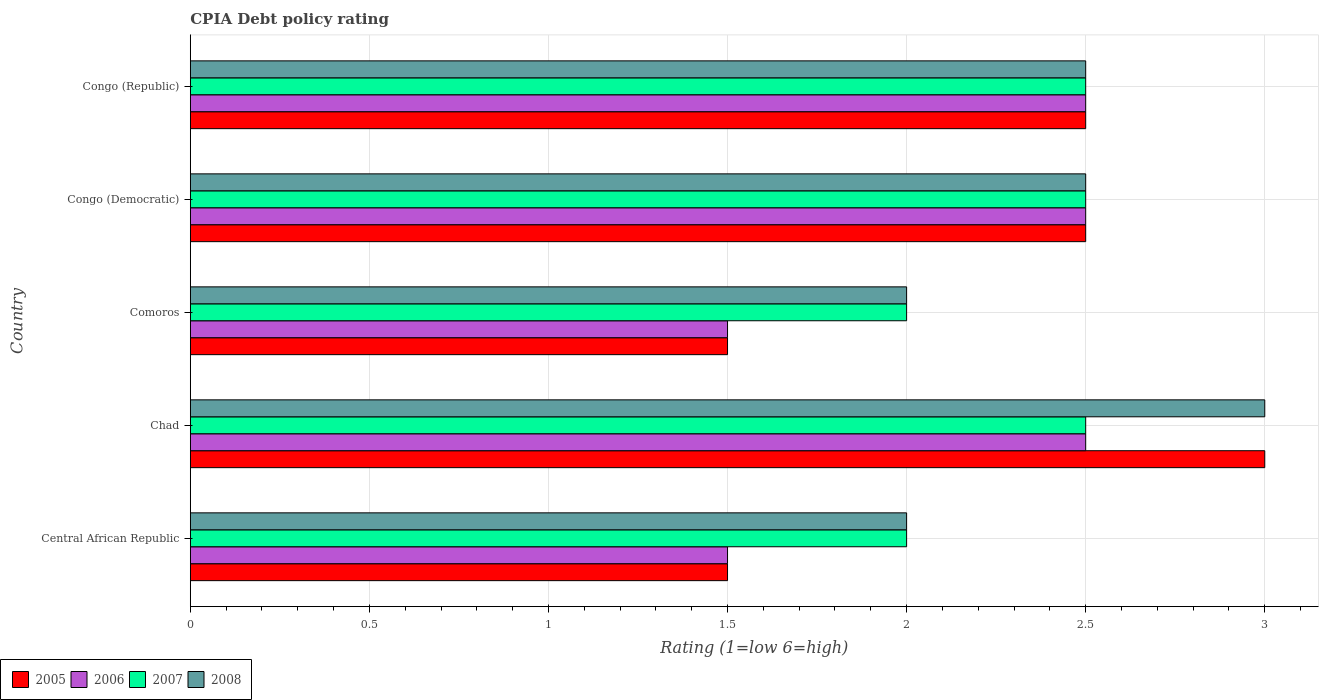How many different coloured bars are there?
Your answer should be very brief. 4. Are the number of bars per tick equal to the number of legend labels?
Your answer should be compact. Yes. How many bars are there on the 3rd tick from the bottom?
Your answer should be very brief. 4. What is the label of the 3rd group of bars from the top?
Your answer should be compact. Comoros. What is the CPIA rating in 2008 in Chad?
Offer a very short reply. 3. Across all countries, what is the maximum CPIA rating in 2007?
Keep it short and to the point. 2.5. Across all countries, what is the minimum CPIA rating in 2007?
Give a very brief answer. 2. In which country was the CPIA rating in 2005 maximum?
Give a very brief answer. Chad. In which country was the CPIA rating in 2007 minimum?
Make the answer very short. Central African Republic. What is the total CPIA rating in 2007 in the graph?
Ensure brevity in your answer.  11.5. What is the difference between the CPIA rating in 2005 in Comoros and that in Congo (Republic)?
Provide a short and direct response. -1. What is the difference between the CPIA rating in 2005 in Congo (Republic) and the CPIA rating in 2008 in Central African Republic?
Keep it short and to the point. 0.5. What is the average CPIA rating in 2007 per country?
Keep it short and to the point. 2.3. What is the ratio of the CPIA rating in 2007 in Central African Republic to that in Comoros?
Your response must be concise. 1. Is the CPIA rating in 2007 in Congo (Democratic) less than that in Congo (Republic)?
Your response must be concise. No. Is the sum of the CPIA rating in 2008 in Congo (Democratic) and Congo (Republic) greater than the maximum CPIA rating in 2005 across all countries?
Keep it short and to the point. Yes. What does the 2nd bar from the top in Comoros represents?
Provide a succinct answer. 2007. How many bars are there?
Your answer should be compact. 20. Are all the bars in the graph horizontal?
Offer a terse response. Yes. How many countries are there in the graph?
Provide a succinct answer. 5. Are the values on the major ticks of X-axis written in scientific E-notation?
Your response must be concise. No. Does the graph contain any zero values?
Your answer should be compact. No. What is the title of the graph?
Your answer should be compact. CPIA Debt policy rating. Does "1988" appear as one of the legend labels in the graph?
Make the answer very short. No. What is the Rating (1=low 6=high) in 2006 in Central African Republic?
Offer a very short reply. 1.5. What is the Rating (1=low 6=high) in 2007 in Central African Republic?
Provide a short and direct response. 2. What is the Rating (1=low 6=high) of 2008 in Central African Republic?
Your answer should be very brief. 2. What is the Rating (1=low 6=high) of 2006 in Chad?
Ensure brevity in your answer.  2.5. What is the Rating (1=low 6=high) in 2008 in Chad?
Ensure brevity in your answer.  3. What is the Rating (1=low 6=high) of 2005 in Comoros?
Offer a terse response. 1.5. What is the Rating (1=low 6=high) of 2006 in Comoros?
Provide a succinct answer. 1.5. What is the Rating (1=low 6=high) of 2008 in Comoros?
Offer a very short reply. 2. What is the Rating (1=low 6=high) of 2005 in Congo (Republic)?
Your answer should be very brief. 2.5. What is the Rating (1=low 6=high) in 2006 in Congo (Republic)?
Your answer should be very brief. 2.5. What is the Rating (1=low 6=high) of 2007 in Congo (Republic)?
Your response must be concise. 2.5. What is the Rating (1=low 6=high) in 2008 in Congo (Republic)?
Your response must be concise. 2.5. Across all countries, what is the maximum Rating (1=low 6=high) of 2005?
Your response must be concise. 3. Across all countries, what is the maximum Rating (1=low 6=high) of 2006?
Offer a terse response. 2.5. Across all countries, what is the minimum Rating (1=low 6=high) in 2005?
Offer a very short reply. 1.5. Across all countries, what is the minimum Rating (1=low 6=high) in 2006?
Keep it short and to the point. 1.5. What is the total Rating (1=low 6=high) of 2006 in the graph?
Your answer should be compact. 10.5. What is the difference between the Rating (1=low 6=high) of 2005 in Central African Republic and that in Chad?
Your answer should be compact. -1.5. What is the difference between the Rating (1=low 6=high) in 2006 in Central African Republic and that in Chad?
Your answer should be compact. -1. What is the difference between the Rating (1=low 6=high) in 2008 in Central African Republic and that in Chad?
Keep it short and to the point. -1. What is the difference between the Rating (1=low 6=high) of 2005 in Central African Republic and that in Comoros?
Your answer should be very brief. 0. What is the difference between the Rating (1=low 6=high) of 2006 in Central African Republic and that in Comoros?
Keep it short and to the point. 0. What is the difference between the Rating (1=low 6=high) in 2008 in Central African Republic and that in Comoros?
Make the answer very short. 0. What is the difference between the Rating (1=low 6=high) in 2005 in Central African Republic and that in Congo (Democratic)?
Offer a terse response. -1. What is the difference between the Rating (1=low 6=high) in 2007 in Central African Republic and that in Congo (Democratic)?
Provide a short and direct response. -0.5. What is the difference between the Rating (1=low 6=high) of 2008 in Central African Republic and that in Congo (Democratic)?
Your response must be concise. -0.5. What is the difference between the Rating (1=low 6=high) in 2007 in Central African Republic and that in Congo (Republic)?
Your answer should be very brief. -0.5. What is the difference between the Rating (1=low 6=high) in 2008 in Central African Republic and that in Congo (Republic)?
Keep it short and to the point. -0.5. What is the difference between the Rating (1=low 6=high) of 2005 in Chad and that in Comoros?
Offer a very short reply. 1.5. What is the difference between the Rating (1=low 6=high) of 2006 in Chad and that in Comoros?
Provide a succinct answer. 1. What is the difference between the Rating (1=low 6=high) of 2007 in Chad and that in Congo (Democratic)?
Your answer should be compact. 0. What is the difference between the Rating (1=low 6=high) in 2008 in Chad and that in Congo (Democratic)?
Ensure brevity in your answer.  0.5. What is the difference between the Rating (1=low 6=high) in 2006 in Chad and that in Congo (Republic)?
Offer a terse response. 0. What is the difference between the Rating (1=low 6=high) in 2007 in Chad and that in Congo (Republic)?
Ensure brevity in your answer.  0. What is the difference between the Rating (1=low 6=high) in 2005 in Comoros and that in Congo (Democratic)?
Your response must be concise. -1. What is the difference between the Rating (1=low 6=high) in 2008 in Comoros and that in Congo (Democratic)?
Offer a terse response. -0.5. What is the difference between the Rating (1=low 6=high) in 2006 in Comoros and that in Congo (Republic)?
Ensure brevity in your answer.  -1. What is the difference between the Rating (1=low 6=high) of 2008 in Comoros and that in Congo (Republic)?
Your answer should be compact. -0.5. What is the difference between the Rating (1=low 6=high) in 2006 in Congo (Democratic) and that in Congo (Republic)?
Your answer should be compact. 0. What is the difference between the Rating (1=low 6=high) of 2005 in Central African Republic and the Rating (1=low 6=high) of 2006 in Chad?
Provide a short and direct response. -1. What is the difference between the Rating (1=low 6=high) of 2005 in Central African Republic and the Rating (1=low 6=high) of 2008 in Chad?
Provide a short and direct response. -1.5. What is the difference between the Rating (1=low 6=high) of 2006 in Central African Republic and the Rating (1=low 6=high) of 2008 in Chad?
Ensure brevity in your answer.  -1.5. What is the difference between the Rating (1=low 6=high) in 2005 in Central African Republic and the Rating (1=low 6=high) in 2006 in Comoros?
Your answer should be compact. 0. What is the difference between the Rating (1=low 6=high) of 2005 in Central African Republic and the Rating (1=low 6=high) of 2007 in Comoros?
Your answer should be very brief. -0.5. What is the difference between the Rating (1=low 6=high) in 2006 in Central African Republic and the Rating (1=low 6=high) in 2008 in Comoros?
Keep it short and to the point. -0.5. What is the difference between the Rating (1=low 6=high) of 2007 in Central African Republic and the Rating (1=low 6=high) of 2008 in Comoros?
Ensure brevity in your answer.  0. What is the difference between the Rating (1=low 6=high) in 2005 in Central African Republic and the Rating (1=low 6=high) in 2008 in Congo (Democratic)?
Provide a succinct answer. -1. What is the difference between the Rating (1=low 6=high) of 2006 in Central African Republic and the Rating (1=low 6=high) of 2007 in Congo (Democratic)?
Your response must be concise. -1. What is the difference between the Rating (1=low 6=high) of 2005 in Central African Republic and the Rating (1=low 6=high) of 2008 in Congo (Republic)?
Your response must be concise. -1. What is the difference between the Rating (1=low 6=high) of 2006 in Central African Republic and the Rating (1=low 6=high) of 2008 in Congo (Republic)?
Your answer should be compact. -1. What is the difference between the Rating (1=low 6=high) of 2007 in Central African Republic and the Rating (1=low 6=high) of 2008 in Congo (Republic)?
Your answer should be very brief. -0.5. What is the difference between the Rating (1=low 6=high) in 2005 in Chad and the Rating (1=low 6=high) in 2008 in Comoros?
Your response must be concise. 1. What is the difference between the Rating (1=low 6=high) in 2006 in Chad and the Rating (1=low 6=high) in 2007 in Comoros?
Provide a short and direct response. 0.5. What is the difference between the Rating (1=low 6=high) of 2006 in Chad and the Rating (1=low 6=high) of 2008 in Comoros?
Give a very brief answer. 0.5. What is the difference between the Rating (1=low 6=high) in 2005 in Chad and the Rating (1=low 6=high) in 2006 in Congo (Republic)?
Your answer should be very brief. 0.5. What is the difference between the Rating (1=low 6=high) in 2005 in Chad and the Rating (1=low 6=high) in 2007 in Congo (Republic)?
Provide a succinct answer. 0.5. What is the difference between the Rating (1=low 6=high) in 2005 in Chad and the Rating (1=low 6=high) in 2008 in Congo (Republic)?
Provide a short and direct response. 0.5. What is the difference between the Rating (1=low 6=high) in 2006 in Chad and the Rating (1=low 6=high) in 2007 in Congo (Republic)?
Offer a terse response. 0. What is the difference between the Rating (1=low 6=high) in 2005 in Comoros and the Rating (1=low 6=high) in 2008 in Congo (Democratic)?
Ensure brevity in your answer.  -1. What is the difference between the Rating (1=low 6=high) of 2006 in Comoros and the Rating (1=low 6=high) of 2007 in Congo (Democratic)?
Offer a very short reply. -1. What is the difference between the Rating (1=low 6=high) of 2007 in Comoros and the Rating (1=low 6=high) of 2008 in Congo (Democratic)?
Your answer should be very brief. -0.5. What is the difference between the Rating (1=low 6=high) of 2006 in Comoros and the Rating (1=low 6=high) of 2008 in Congo (Republic)?
Ensure brevity in your answer.  -1. What is the difference between the Rating (1=low 6=high) in 2007 in Comoros and the Rating (1=low 6=high) in 2008 in Congo (Republic)?
Your response must be concise. -0.5. What is the difference between the Rating (1=low 6=high) of 2005 in Congo (Democratic) and the Rating (1=low 6=high) of 2008 in Congo (Republic)?
Give a very brief answer. 0. What is the difference between the Rating (1=low 6=high) in 2006 in Congo (Democratic) and the Rating (1=low 6=high) in 2007 in Congo (Republic)?
Your response must be concise. 0. What is the difference between the Rating (1=low 6=high) in 2007 in Congo (Democratic) and the Rating (1=low 6=high) in 2008 in Congo (Republic)?
Your answer should be very brief. 0. What is the average Rating (1=low 6=high) of 2005 per country?
Ensure brevity in your answer.  2.2. What is the average Rating (1=low 6=high) of 2006 per country?
Your answer should be compact. 2.1. What is the average Rating (1=low 6=high) of 2007 per country?
Keep it short and to the point. 2.3. What is the difference between the Rating (1=low 6=high) of 2005 and Rating (1=low 6=high) of 2007 in Central African Republic?
Your answer should be very brief. -0.5. What is the difference between the Rating (1=low 6=high) of 2006 and Rating (1=low 6=high) of 2007 in Central African Republic?
Make the answer very short. -0.5. What is the difference between the Rating (1=low 6=high) of 2005 and Rating (1=low 6=high) of 2006 in Chad?
Your response must be concise. 0.5. What is the difference between the Rating (1=low 6=high) in 2005 and Rating (1=low 6=high) in 2008 in Chad?
Give a very brief answer. 0. What is the difference between the Rating (1=low 6=high) of 2007 and Rating (1=low 6=high) of 2008 in Chad?
Your response must be concise. -0.5. What is the difference between the Rating (1=low 6=high) in 2005 and Rating (1=low 6=high) in 2007 in Comoros?
Your answer should be very brief. -0.5. What is the difference between the Rating (1=low 6=high) of 2005 and Rating (1=low 6=high) of 2008 in Comoros?
Give a very brief answer. -0.5. What is the difference between the Rating (1=low 6=high) of 2006 and Rating (1=low 6=high) of 2007 in Comoros?
Keep it short and to the point. -0.5. What is the difference between the Rating (1=low 6=high) in 2006 and Rating (1=low 6=high) in 2008 in Comoros?
Offer a terse response. -0.5. What is the difference between the Rating (1=low 6=high) of 2007 and Rating (1=low 6=high) of 2008 in Comoros?
Give a very brief answer. 0. What is the difference between the Rating (1=low 6=high) of 2005 and Rating (1=low 6=high) of 2006 in Congo (Republic)?
Provide a succinct answer. 0. What is the difference between the Rating (1=low 6=high) of 2005 and Rating (1=low 6=high) of 2007 in Congo (Republic)?
Ensure brevity in your answer.  0. What is the difference between the Rating (1=low 6=high) in 2005 and Rating (1=low 6=high) in 2008 in Congo (Republic)?
Keep it short and to the point. 0. What is the difference between the Rating (1=low 6=high) in 2006 and Rating (1=low 6=high) in 2007 in Congo (Republic)?
Keep it short and to the point. 0. What is the difference between the Rating (1=low 6=high) of 2006 and Rating (1=low 6=high) of 2008 in Congo (Republic)?
Provide a succinct answer. 0. What is the ratio of the Rating (1=low 6=high) of 2007 in Central African Republic to that in Chad?
Provide a short and direct response. 0.8. What is the ratio of the Rating (1=low 6=high) of 2005 in Central African Republic to that in Comoros?
Your answer should be compact. 1. What is the ratio of the Rating (1=low 6=high) of 2006 in Central African Republic to that in Comoros?
Your answer should be compact. 1. What is the ratio of the Rating (1=low 6=high) in 2008 in Central African Republic to that in Comoros?
Keep it short and to the point. 1. What is the ratio of the Rating (1=low 6=high) in 2005 in Central African Republic to that in Congo (Democratic)?
Provide a short and direct response. 0.6. What is the ratio of the Rating (1=low 6=high) in 2008 in Central African Republic to that in Congo (Democratic)?
Your response must be concise. 0.8. What is the ratio of the Rating (1=low 6=high) in 2007 in Central African Republic to that in Congo (Republic)?
Provide a succinct answer. 0.8. What is the ratio of the Rating (1=low 6=high) in 2008 in Central African Republic to that in Congo (Republic)?
Provide a succinct answer. 0.8. What is the ratio of the Rating (1=low 6=high) in 2005 in Chad to that in Congo (Democratic)?
Make the answer very short. 1.2. What is the ratio of the Rating (1=low 6=high) in 2008 in Chad to that in Congo (Democratic)?
Provide a short and direct response. 1.2. What is the ratio of the Rating (1=low 6=high) in 2007 in Chad to that in Congo (Republic)?
Provide a short and direct response. 1. What is the ratio of the Rating (1=low 6=high) of 2008 in Chad to that in Congo (Republic)?
Ensure brevity in your answer.  1.2. What is the ratio of the Rating (1=low 6=high) of 2005 in Comoros to that in Congo (Democratic)?
Offer a terse response. 0.6. What is the ratio of the Rating (1=low 6=high) of 2008 in Comoros to that in Congo (Democratic)?
Your answer should be very brief. 0.8. What is the ratio of the Rating (1=low 6=high) of 2008 in Congo (Democratic) to that in Congo (Republic)?
Offer a very short reply. 1. What is the difference between the highest and the second highest Rating (1=low 6=high) of 2005?
Keep it short and to the point. 0.5. What is the difference between the highest and the second highest Rating (1=low 6=high) of 2007?
Your answer should be compact. 0. What is the difference between the highest and the lowest Rating (1=low 6=high) of 2005?
Provide a short and direct response. 1.5. 